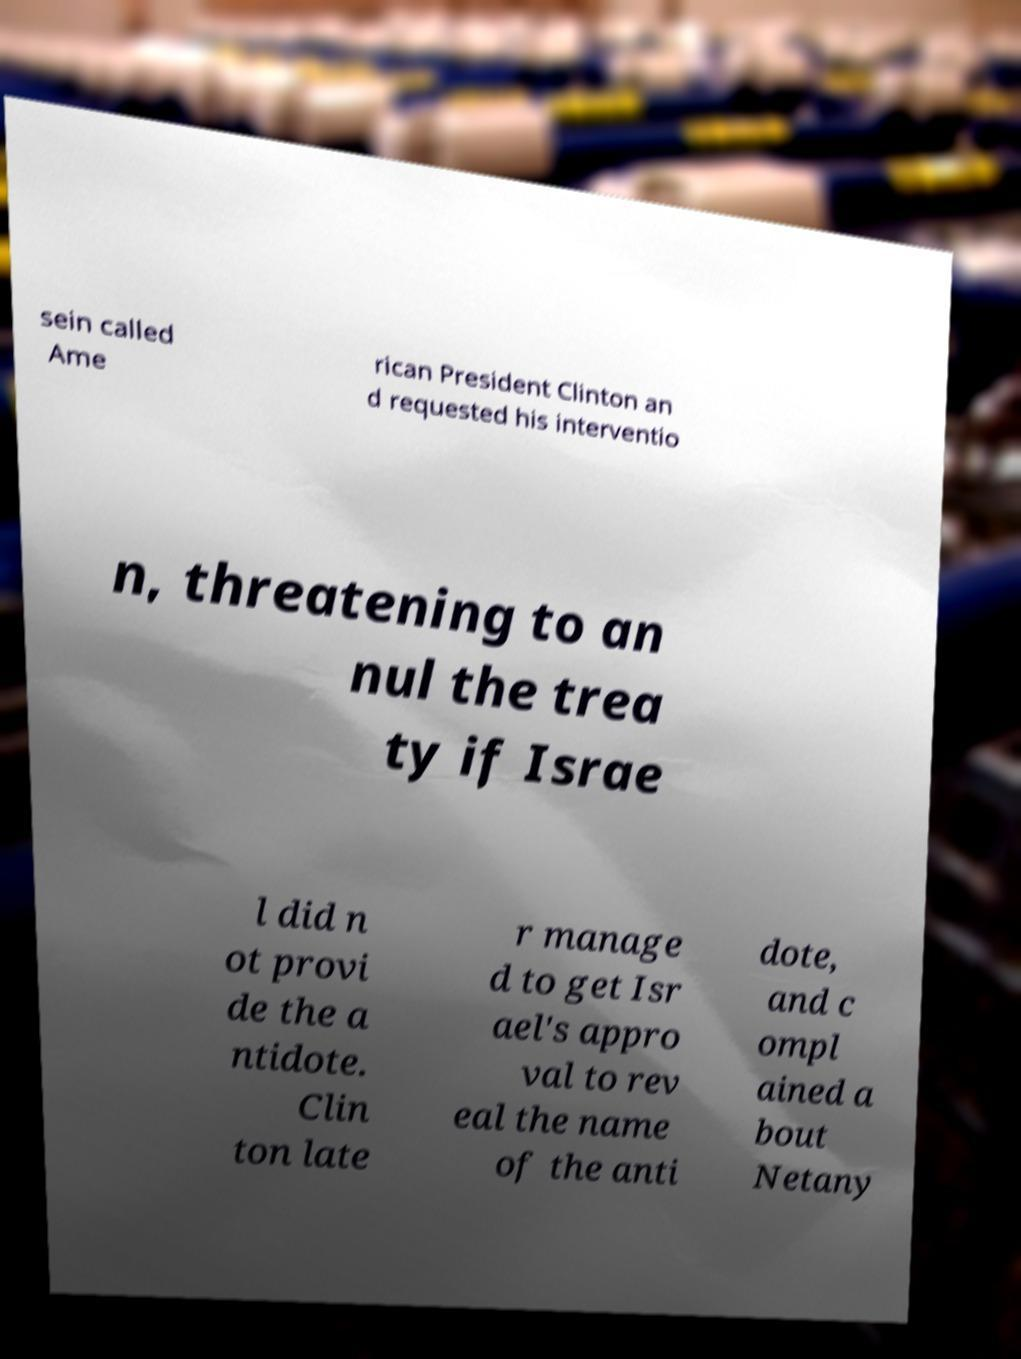Could you extract and type out the text from this image? sein called Ame rican President Clinton an d requested his interventio n, threatening to an nul the trea ty if Israe l did n ot provi de the a ntidote. Clin ton late r manage d to get Isr ael's appro val to rev eal the name of the anti dote, and c ompl ained a bout Netany 